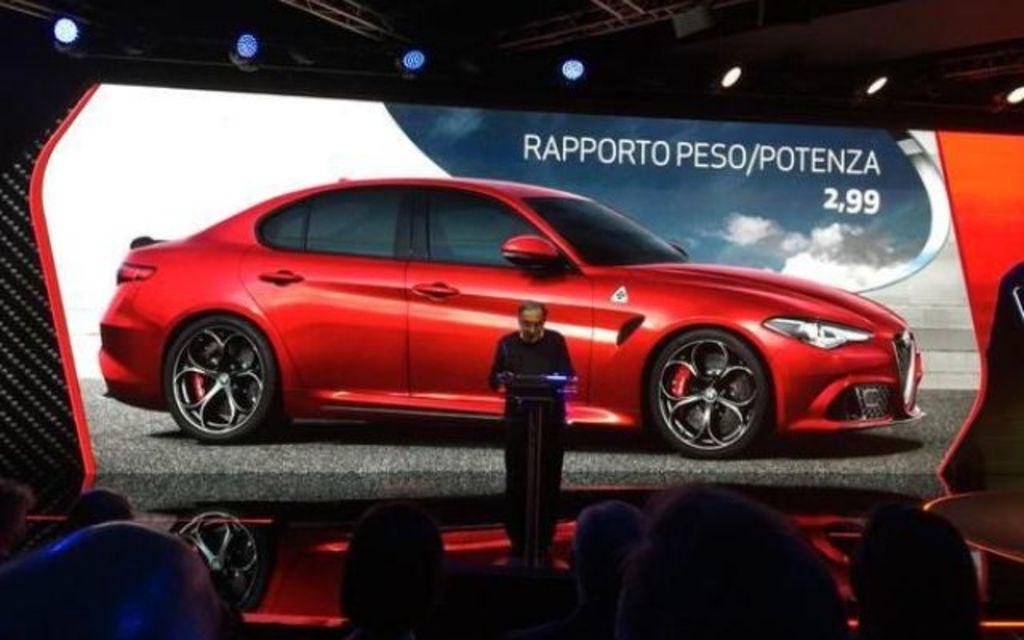Please provide a concise description of this image. In this picture there is a man who is standing near to the speech desk. In the back we can see banner which showing a red car. On the bottom we can see group of persons. On the top we can see lights. 